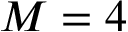<formula> <loc_0><loc_0><loc_500><loc_500>M = 4</formula> 